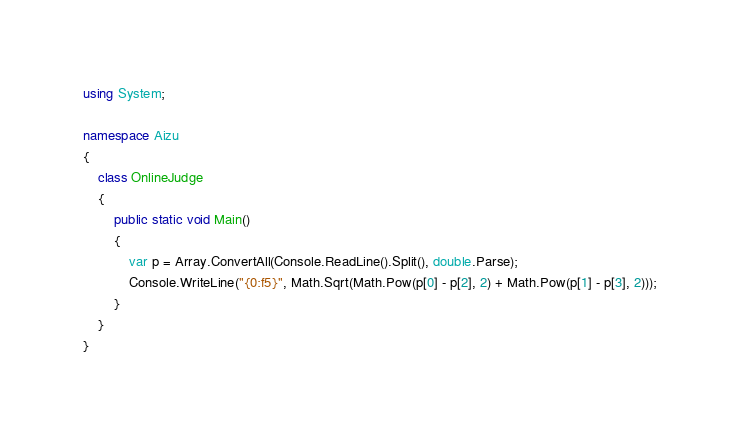<code> <loc_0><loc_0><loc_500><loc_500><_C#_>using System;

namespace Aizu
{
    class OnlineJudge
    {
        public static void Main()
        {
            var p = Array.ConvertAll(Console.ReadLine().Split(), double.Parse);
            Console.WriteLine("{0:f5}", Math.Sqrt(Math.Pow(p[0] - p[2], 2) + Math.Pow(p[1] - p[3], 2)));
        }
    }
}</code> 